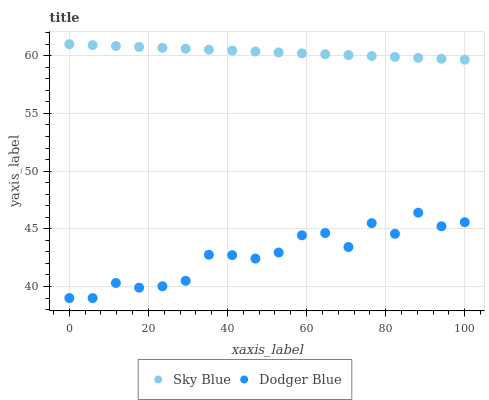Does Dodger Blue have the minimum area under the curve?
Answer yes or no. Yes. Does Sky Blue have the maximum area under the curve?
Answer yes or no. Yes. Does Dodger Blue have the maximum area under the curve?
Answer yes or no. No. Is Sky Blue the smoothest?
Answer yes or no. Yes. Is Dodger Blue the roughest?
Answer yes or no. Yes. Is Dodger Blue the smoothest?
Answer yes or no. No. Does Dodger Blue have the lowest value?
Answer yes or no. Yes. Does Sky Blue have the highest value?
Answer yes or no. Yes. Does Dodger Blue have the highest value?
Answer yes or no. No. Is Dodger Blue less than Sky Blue?
Answer yes or no. Yes. Is Sky Blue greater than Dodger Blue?
Answer yes or no. Yes. Does Dodger Blue intersect Sky Blue?
Answer yes or no. No. 